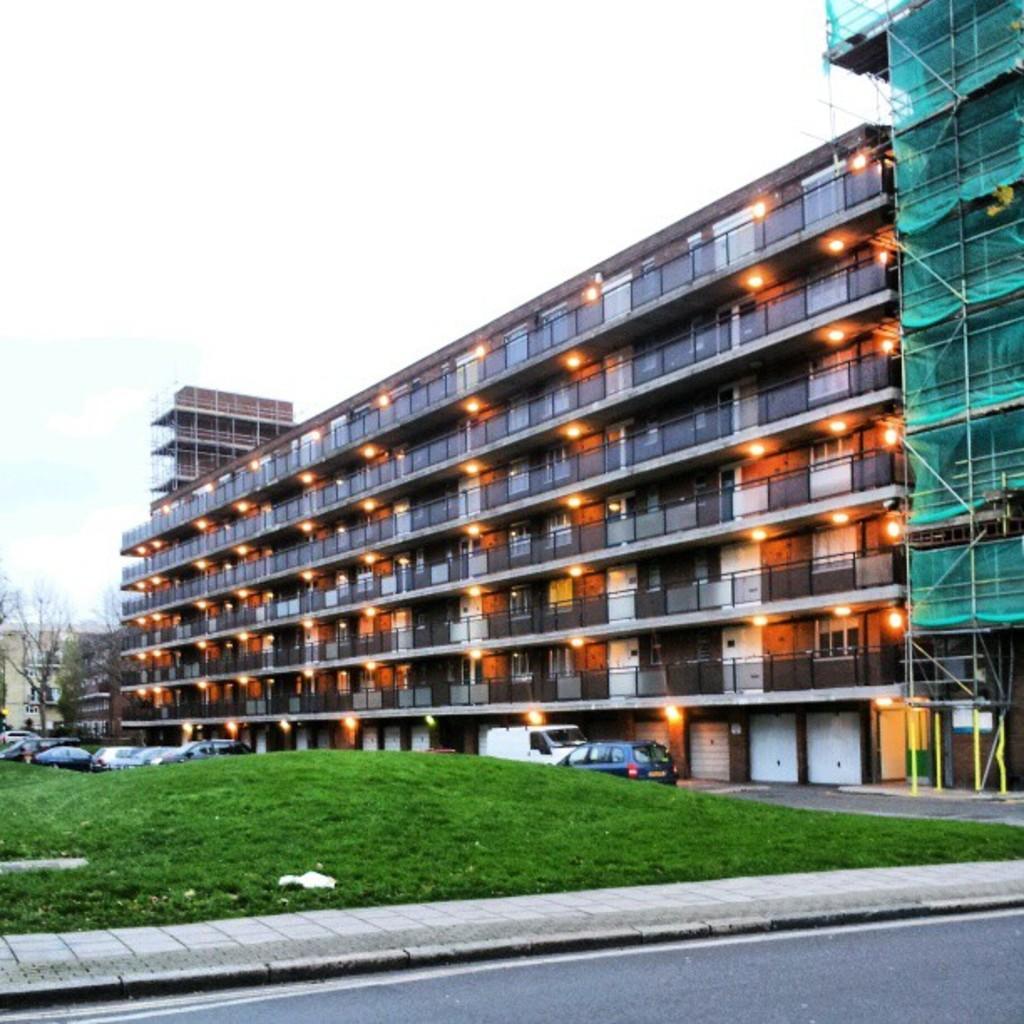Describe this image in one or two sentences. These are the buildings with the glass doors and lights. I can see the vehicles, which are parked. Here is the grass. In the background, that looks like a tree. This is the sky. This looks like a road. 